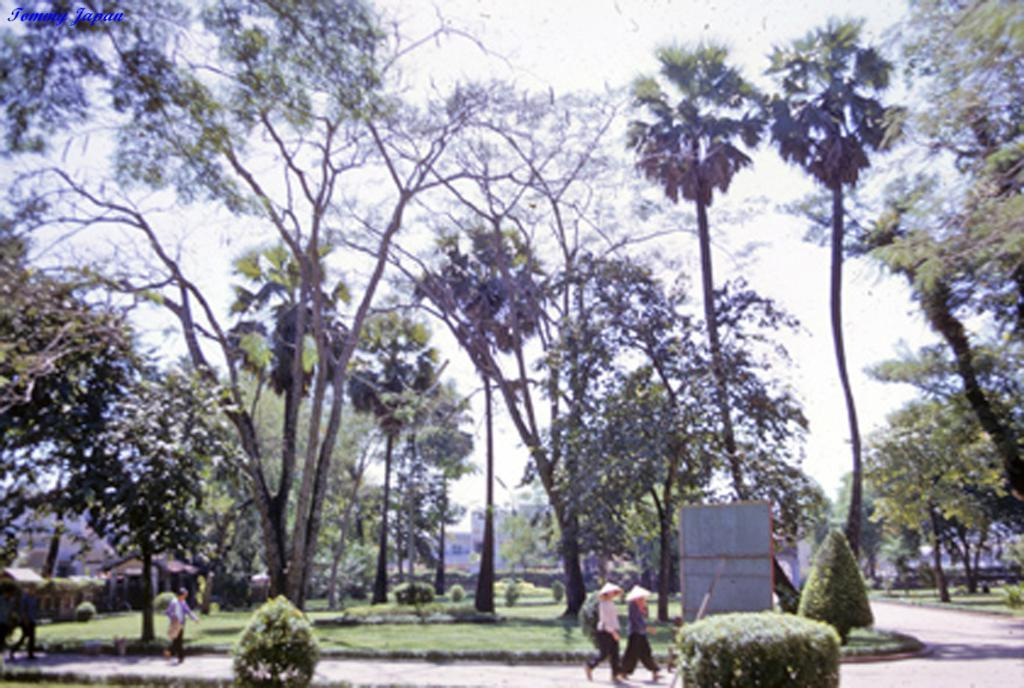What can be seen in the foreground of the image? In the foreground of the image, there are plants, grass, persons walking on a path, and a board. What type of vegetation is present in the foreground? There are plants and grass in the foreground of the image. What are the people in the image doing? The persons in the image are walking on a path in the foreground. What can be seen in the background of the image? In the background of the image, there are trees, buildings, and the sky. Are there any icicles hanging from the trees in the image? There is no mention of icicles in the provided facts, and therefore it cannot be determined if any are present in the image. What attempt is being made by the persons in the image? The provided facts do not mention any attempts being made by the persons in the image. 